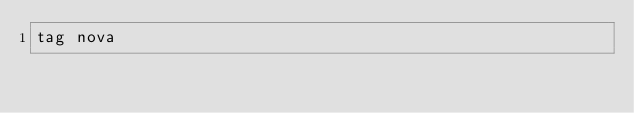<code> <loc_0><loc_0><loc_500><loc_500><_Python_>tag nova
</code> 